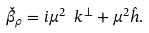<formula> <loc_0><loc_0><loc_500><loc_500>\check { \beta } _ { \rho } = i \mu ^ { 2 } \ k ^ { \perp } + \mu ^ { 2 } \hat { h } .</formula> 